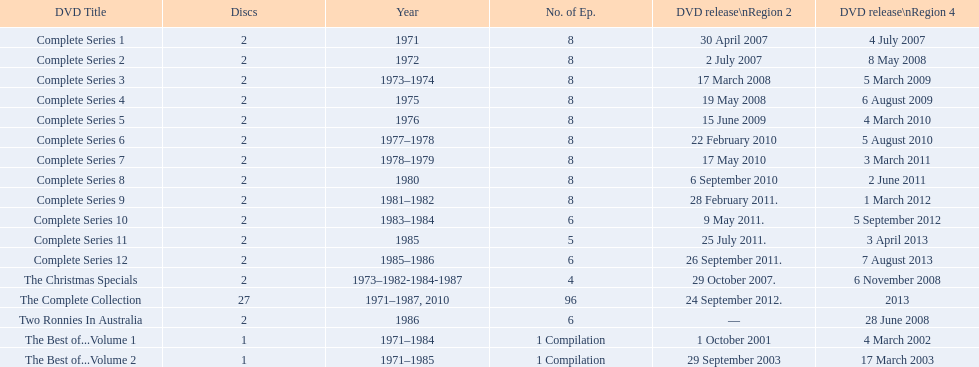Which element precedes the completion of series 10? Complete Series 9. 